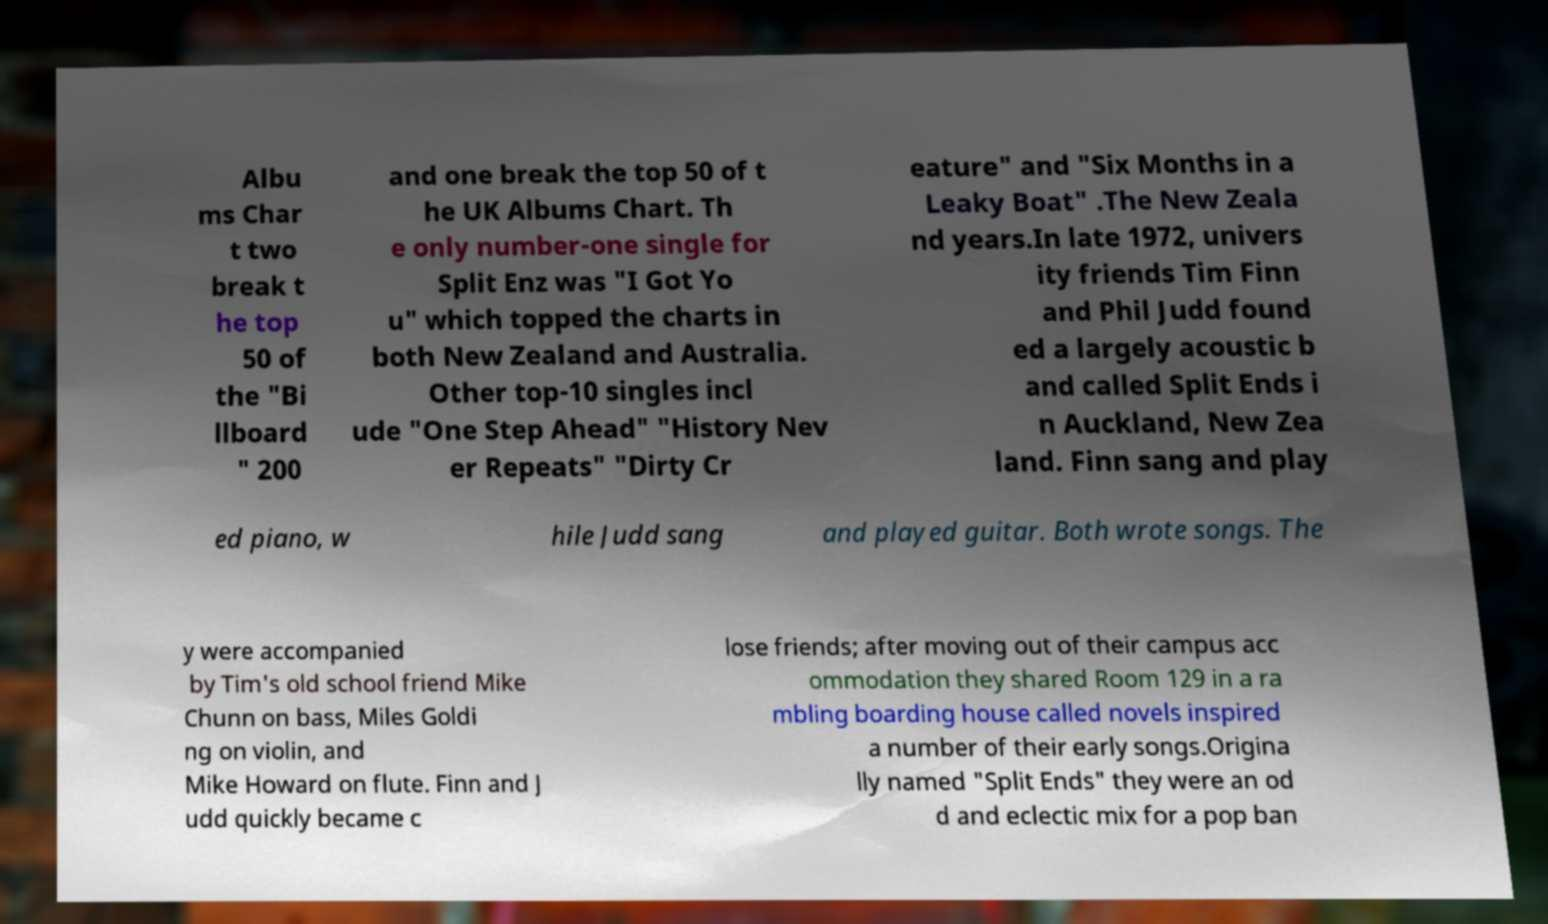Please read and relay the text visible in this image. What does it say? Albu ms Char t two break t he top 50 of the "Bi llboard " 200 and one break the top 50 of t he UK Albums Chart. Th e only number-one single for Split Enz was "I Got Yo u" which topped the charts in both New Zealand and Australia. Other top-10 singles incl ude "One Step Ahead" "History Nev er Repeats" "Dirty Cr eature" and "Six Months in a Leaky Boat" .The New Zeala nd years.In late 1972, univers ity friends Tim Finn and Phil Judd found ed a largely acoustic b and called Split Ends i n Auckland, New Zea land. Finn sang and play ed piano, w hile Judd sang and played guitar. Both wrote songs. The y were accompanied by Tim's old school friend Mike Chunn on bass, Miles Goldi ng on violin, and Mike Howard on flute. Finn and J udd quickly became c lose friends; after moving out of their campus acc ommodation they shared Room 129 in a ra mbling boarding house called novels inspired a number of their early songs.Origina lly named "Split Ends" they were an od d and eclectic mix for a pop ban 